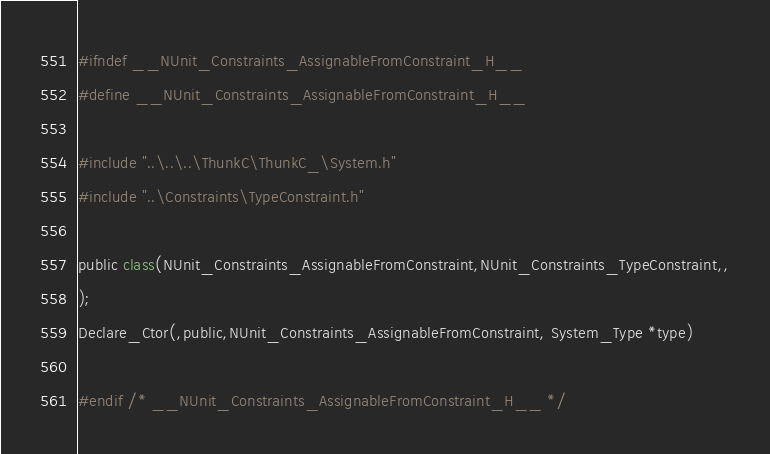<code> <loc_0><loc_0><loc_500><loc_500><_C_>#ifndef __NUnit_Constraints_AssignableFromConstraint_H__
#define __NUnit_Constraints_AssignableFromConstraint_H__

#include "..\..\..\ThunkC\ThunkC_\System.h"
#include "..\Constraints\TypeConstraint.h"

public class(NUnit_Constraints_AssignableFromConstraint,NUnit_Constraints_TypeConstraint,,
);
Declare_Ctor(,public,NUnit_Constraints_AssignableFromConstraint, System_Type *type)

#endif /* __NUnit_Constraints_AssignableFromConstraint_H__ */



</code> 